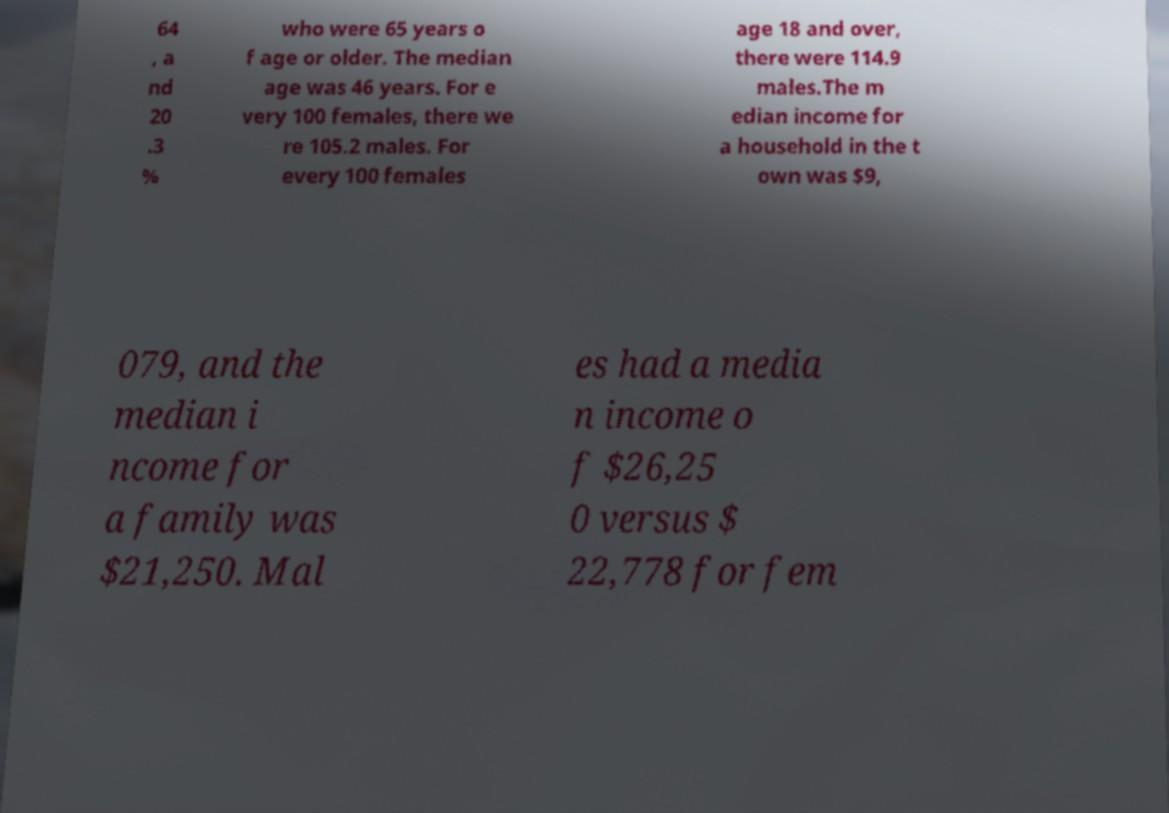Could you assist in decoding the text presented in this image and type it out clearly? 64 , a nd 20 .3 % who were 65 years o f age or older. The median age was 46 years. For e very 100 females, there we re 105.2 males. For every 100 females age 18 and over, there were 114.9 males.The m edian income for a household in the t own was $9, 079, and the median i ncome for a family was $21,250. Mal es had a media n income o f $26,25 0 versus $ 22,778 for fem 